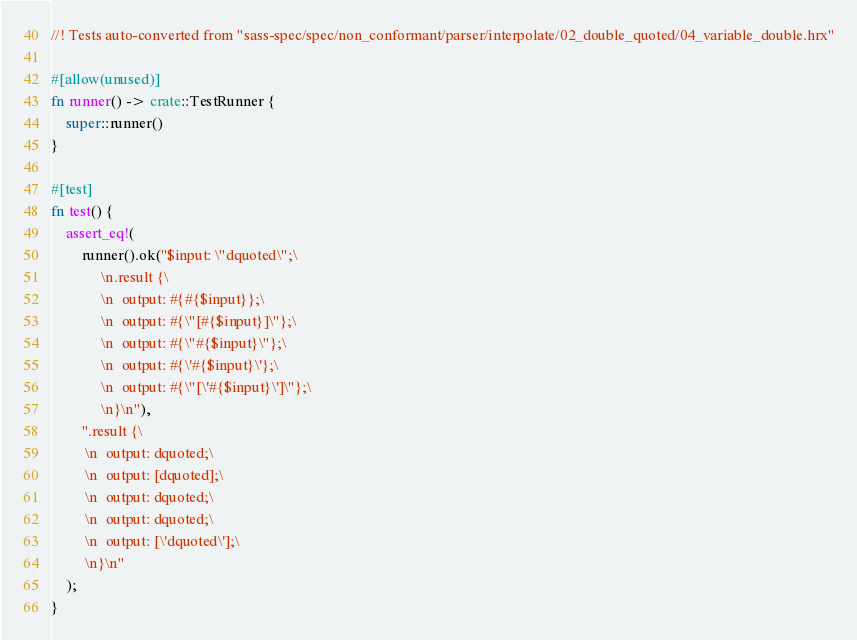<code> <loc_0><loc_0><loc_500><loc_500><_Rust_>//! Tests auto-converted from "sass-spec/spec/non_conformant/parser/interpolate/02_double_quoted/04_variable_double.hrx"

#[allow(unused)]
fn runner() -> crate::TestRunner {
    super::runner()
}

#[test]
fn test() {
    assert_eq!(
        runner().ok("$input: \"dquoted\";\
             \n.result {\
             \n  output: #{#{$input}};\
             \n  output: #{\"[#{$input}]\"};\
             \n  output: #{\"#{$input}\"};\
             \n  output: #{\'#{$input}\'};\
             \n  output: #{\"[\'#{$input}\']\"};\
             \n}\n"),
        ".result {\
         \n  output: dquoted;\
         \n  output: [dquoted];\
         \n  output: dquoted;\
         \n  output: dquoted;\
         \n  output: [\'dquoted\'];\
         \n}\n"
    );
}
</code> 